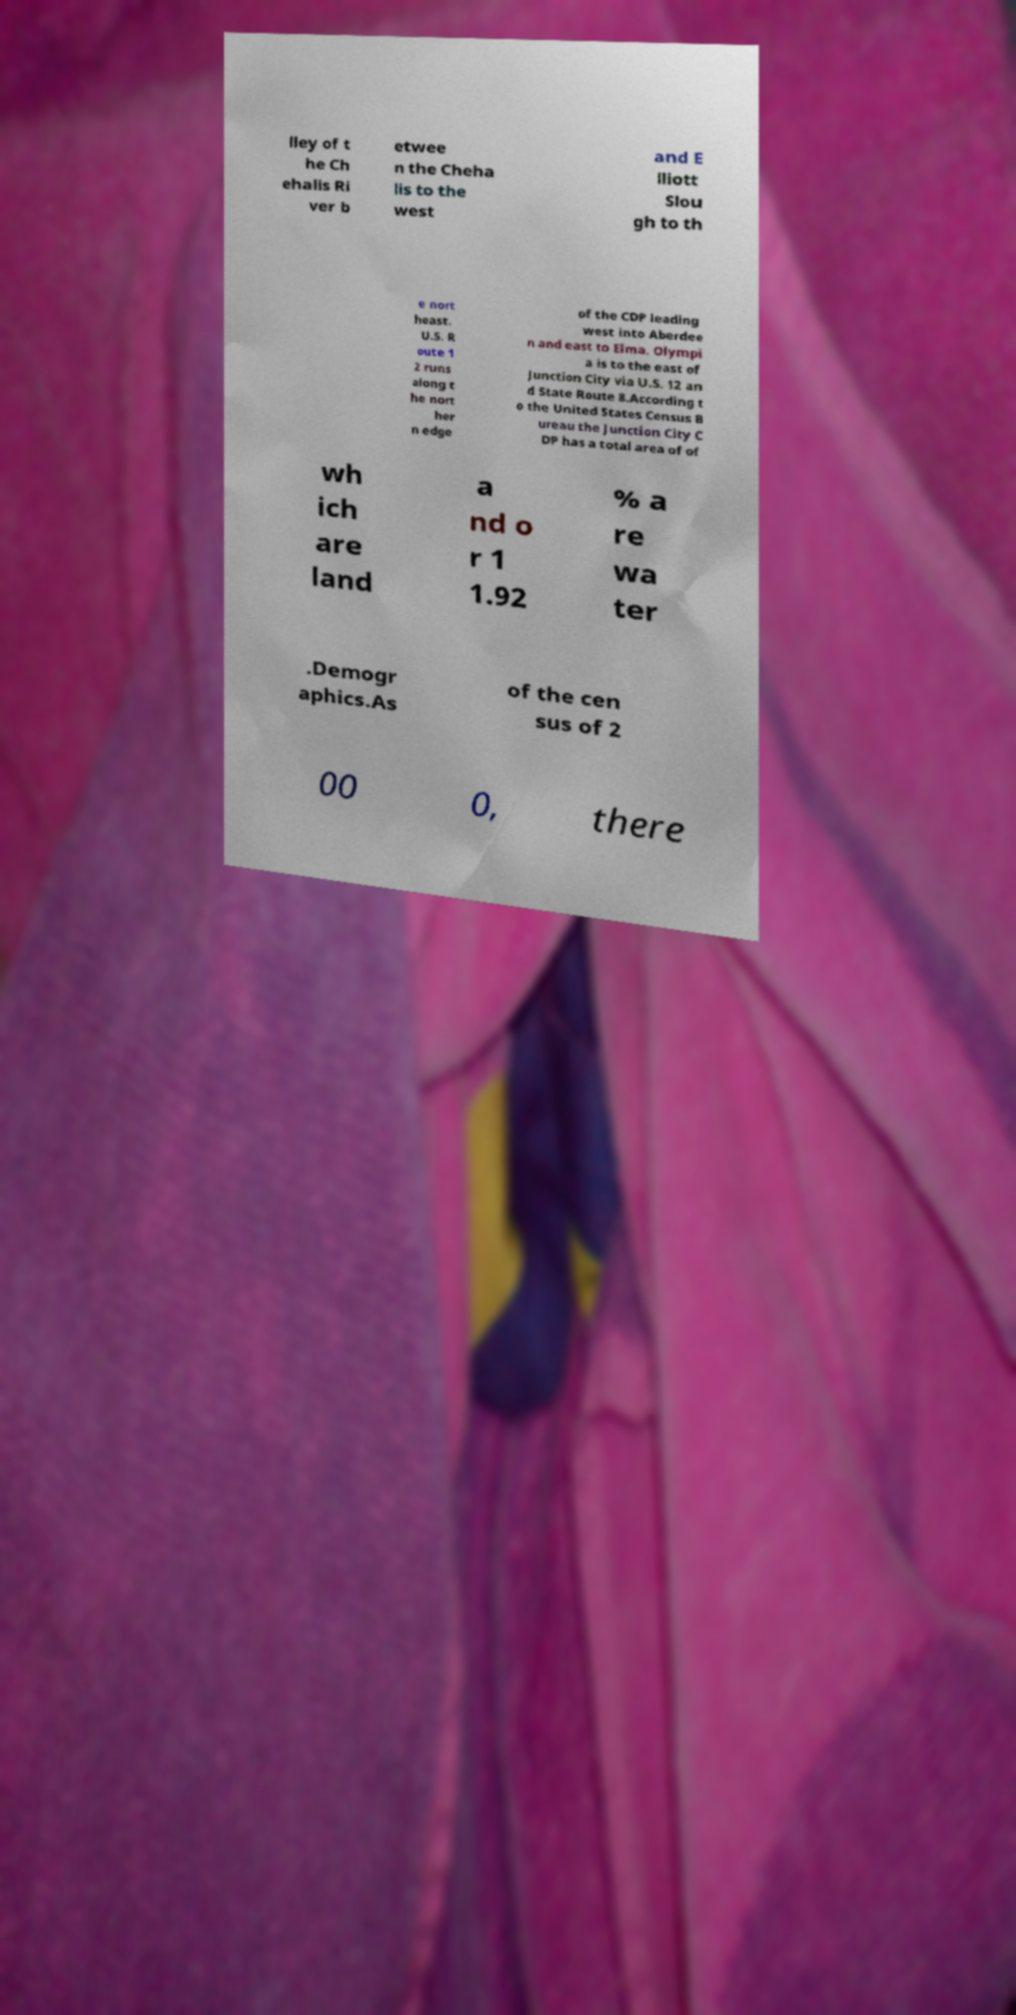Please read and relay the text visible in this image. What does it say? lley of t he Ch ehalis Ri ver b etwee n the Cheha lis to the west and E lliott Slou gh to th e nort heast. U.S. R oute 1 2 runs along t he nort her n edge of the CDP leading west into Aberdee n and east to Elma. Olympi a is to the east of Junction City via U.S. 12 an d State Route 8.According t o the United States Census B ureau the Junction City C DP has a total area of of wh ich are land a nd o r 1 1.92 % a re wa ter .Demogr aphics.As of the cen sus of 2 00 0, there 